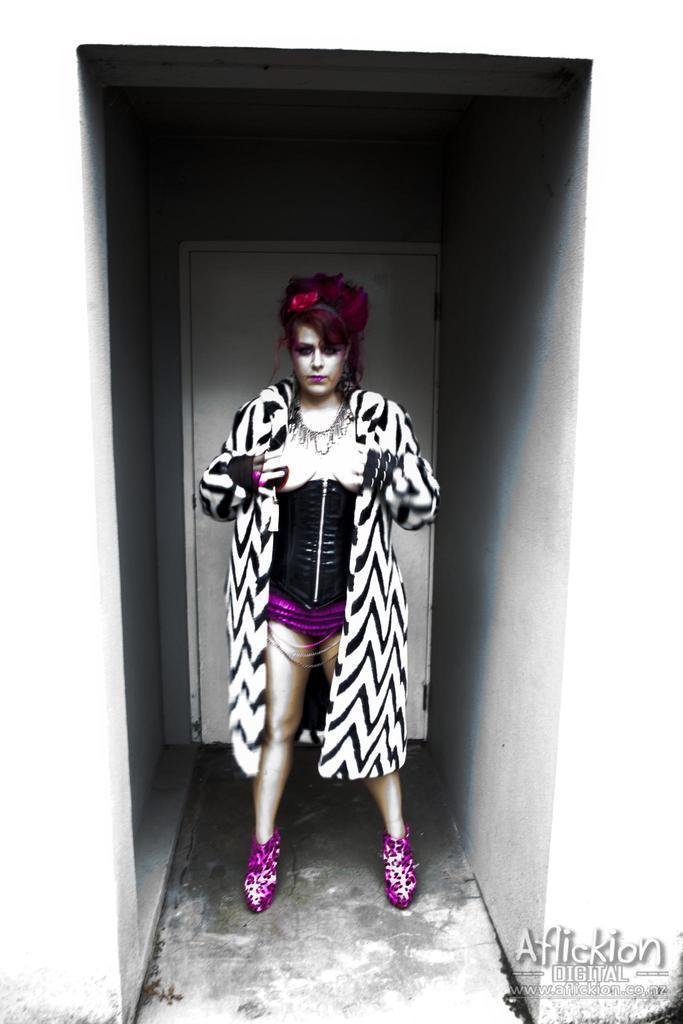Can you describe this image briefly? In this image a woman wearing a jacket is standing on the floor. Behind her there is a door to the wall. 